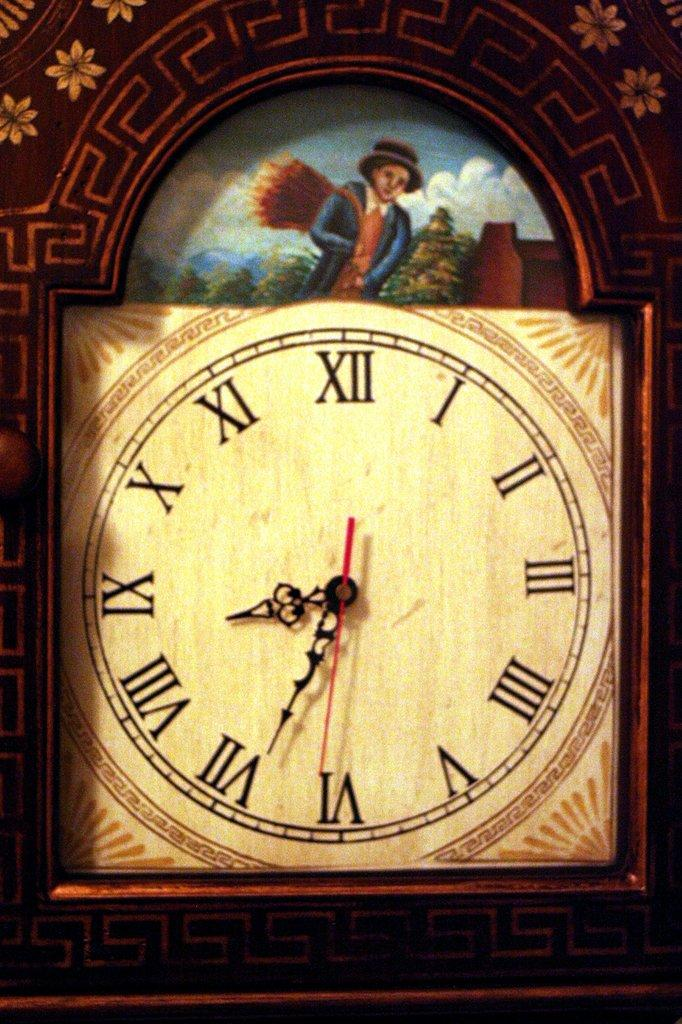What object in the image can be used to tell time? There is a clock in the image that can be used to tell time. What type of image is present in the image? There is a cartoon image of a person in the image. What is the limit of the voyage depicted in the image? There is no voyage depicted in the image, as it only features a clock and a cartoon image of a person. 